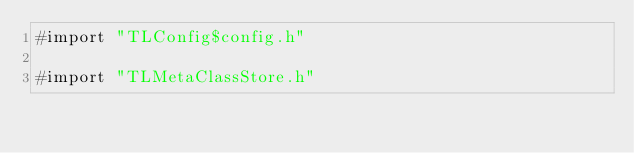Convert code to text. <code><loc_0><loc_0><loc_500><loc_500><_ObjectiveC_>#import "TLConfig$config.h"

#import "TLMetaClassStore.h"
</code> 